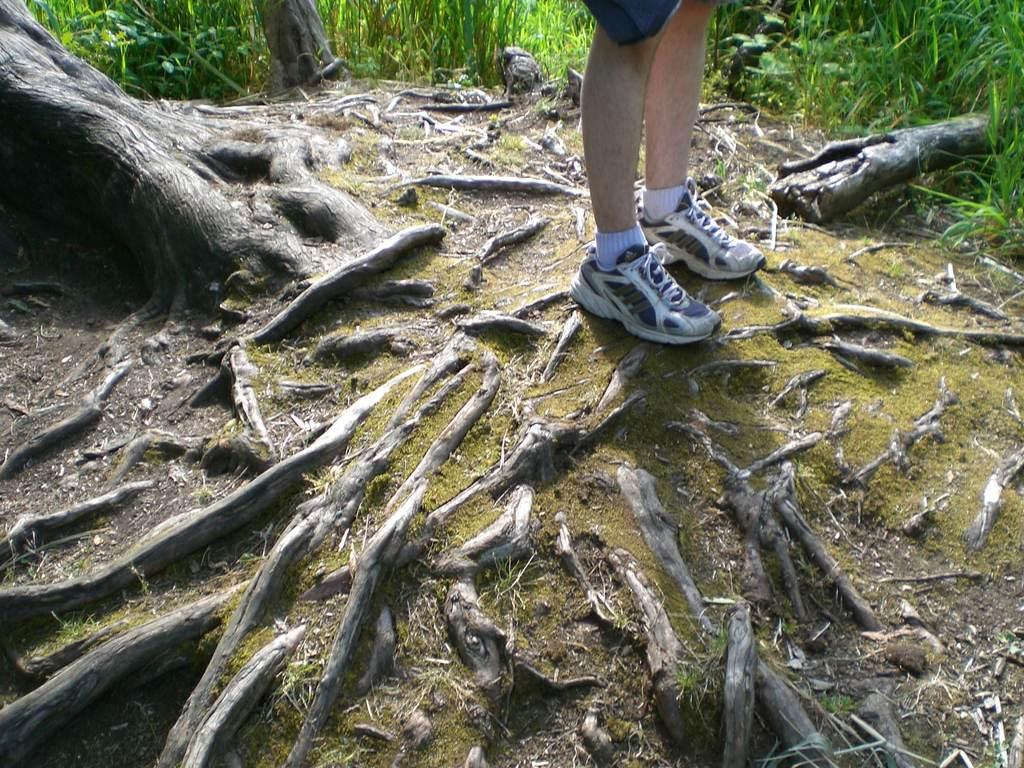What part of a person can be seen in the image? There are legs of a person in the image. What type of surface is visible beneath the person? The ground is visible in the image. What kind of vegetation is present on the ground? There is grass on the ground. What else can be seen on the ground in the image? There are roots visible on the ground. What structures are present in the image that are not part of the person or vegetation? There are tree trunks and broken wood in the image. What type of care is being provided to the stem in the image? There is no stem present in the image, so no care is being provided. 